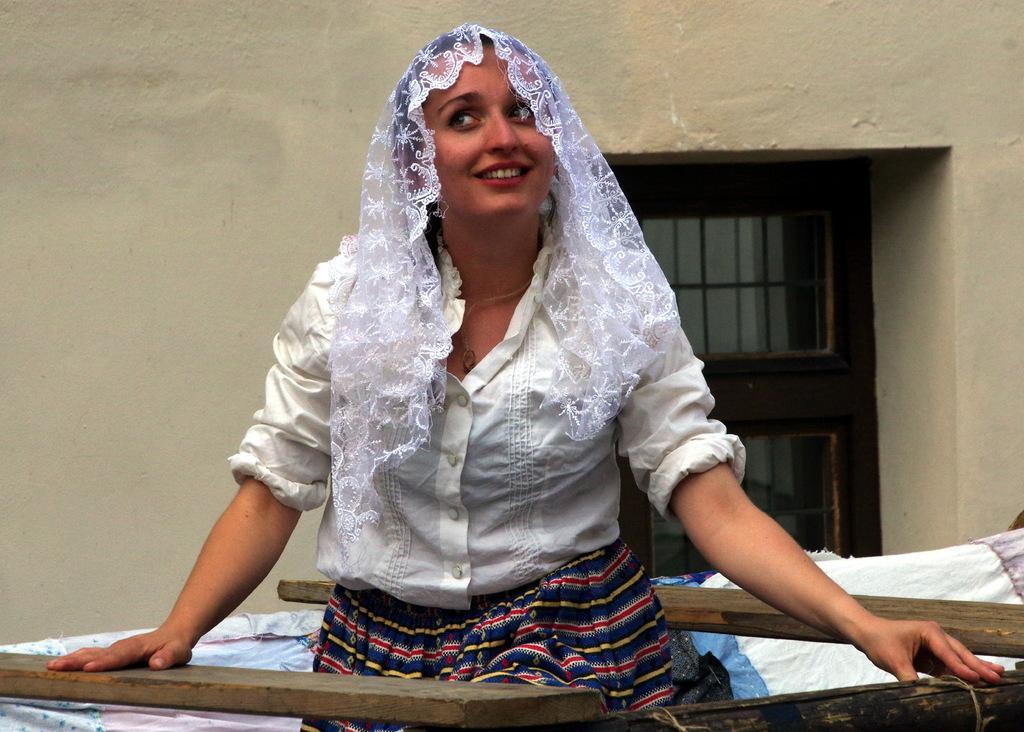In one or two sentences, can you explain what this image depicts? In this image in the center there is one woman, and at the bottom there are some clothes and some wooden sticks. In the background there is wall and window. 